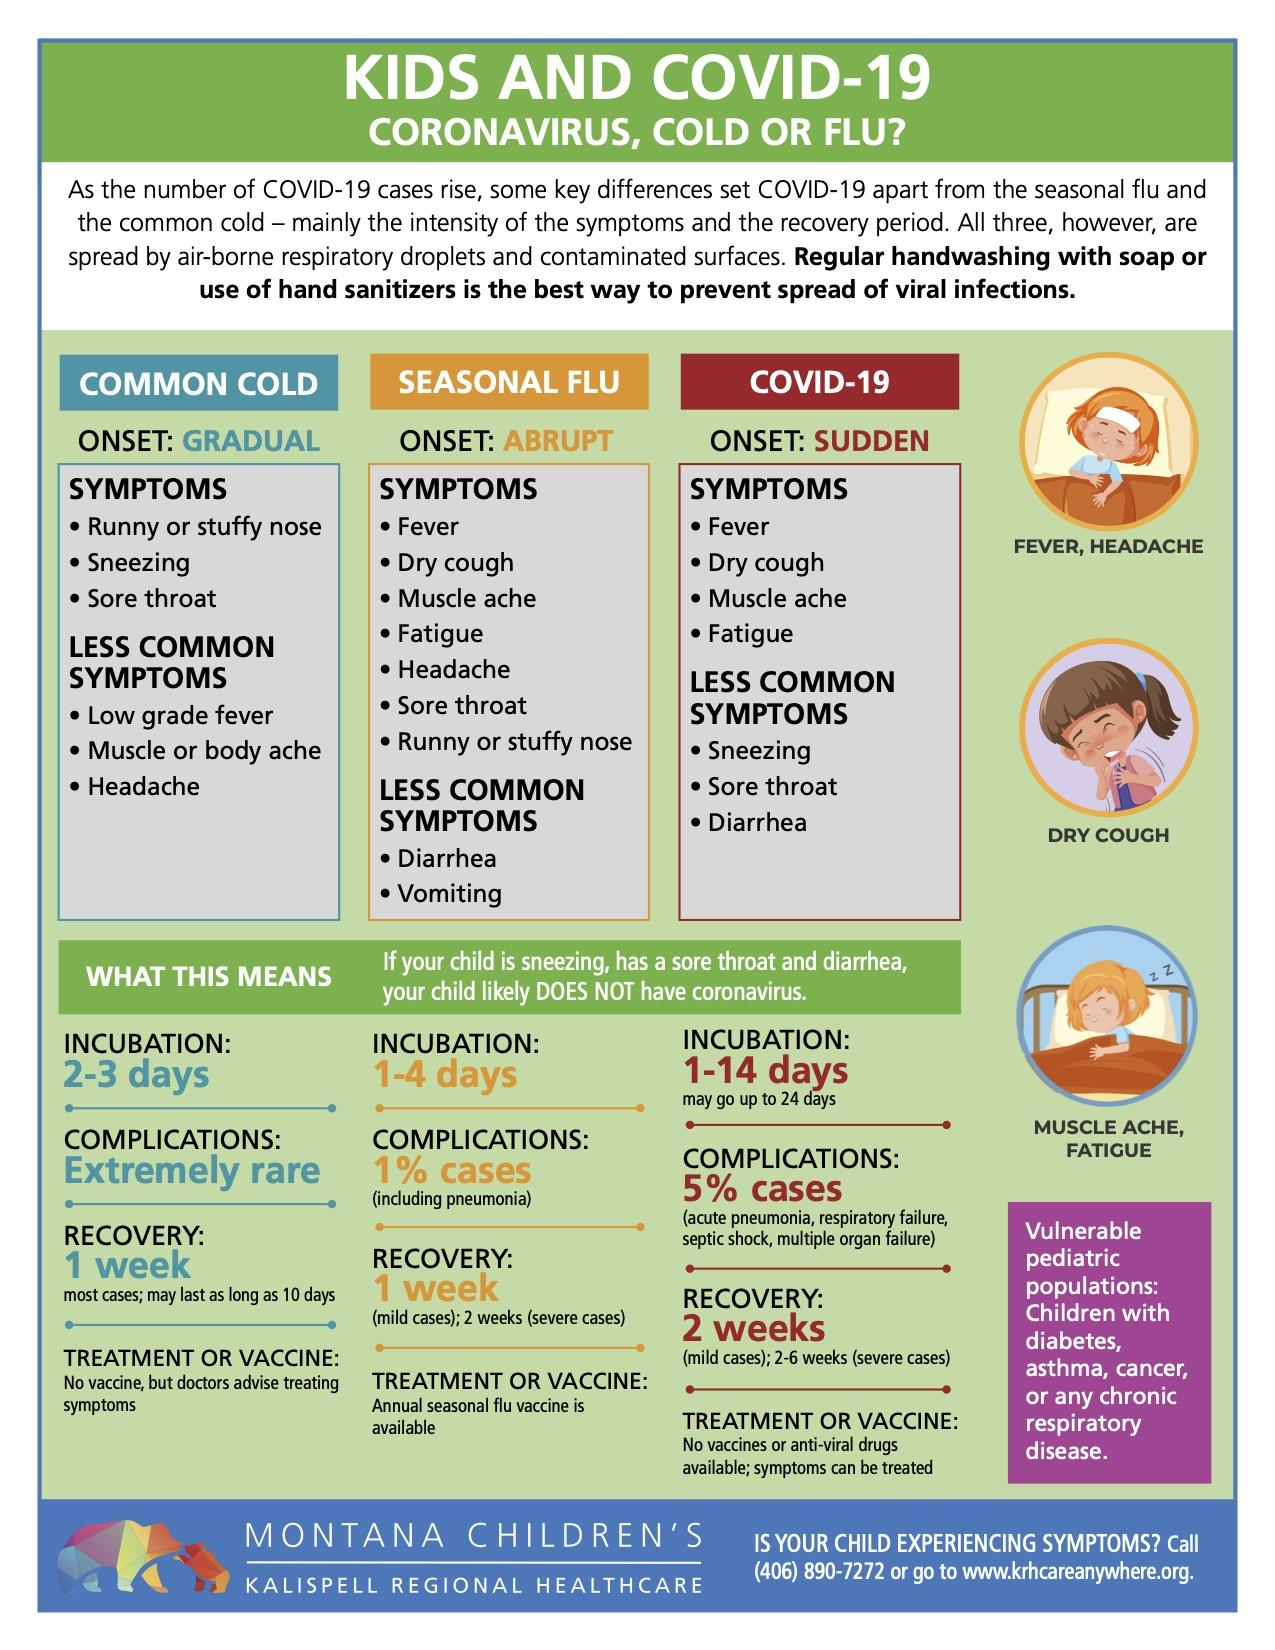Identify some key points in this picture. Diarrhea is a symptom of several illnesses, including seasonal flu and COVID-19. The two illnesses that have a recovery time of one week are the common cold and the seasonal flu. The infographic shows three children. Seasonal flu and COVID-19 are both illnesses that commonly present with the symptom of fatigue. It is expected that complications related to the common cold will occur in less than 1% of cases. 